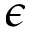<formula> <loc_0><loc_0><loc_500><loc_500>\epsilon</formula> 